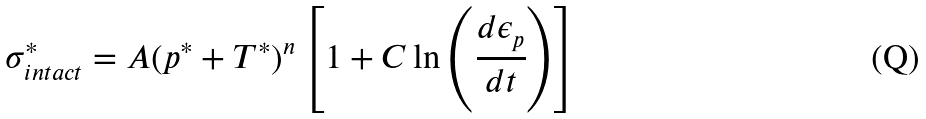Convert formula to latex. <formula><loc_0><loc_0><loc_500><loc_500>\sigma _ { i n t a c t } ^ { * } = A ( p ^ { * } + T ^ { * } ) ^ { n } \left [ 1 + C \ln \left ( { \cfrac { d \epsilon _ { p } } { d t } } \right ) \right ]</formula> 